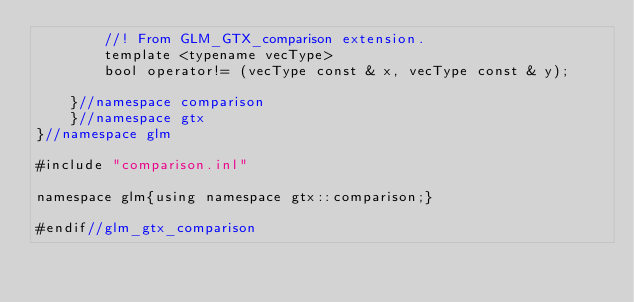<code> <loc_0><loc_0><loc_500><loc_500><_C++_>		//! From GLM_GTX_comparison extension.
		template <typename vecType>
		bool operator!= (vecType const & x, vecType const & y);

	}//namespace comparison
	}//namespace gtx
}//namespace glm

#include "comparison.inl"

namespace glm{using namespace gtx::comparison;}

#endif//glm_gtx_comparison
</code> 